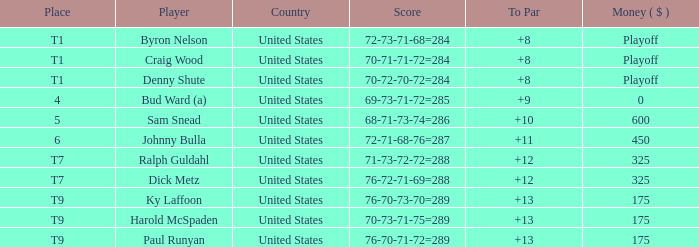What's the money that Sam Snead won? 600.0. 